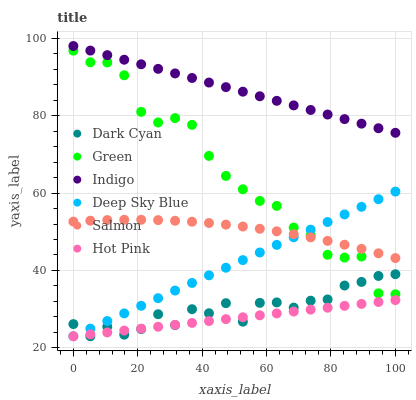Does Hot Pink have the minimum area under the curve?
Answer yes or no. Yes. Does Indigo have the maximum area under the curve?
Answer yes or no. Yes. Does Salmon have the minimum area under the curve?
Answer yes or no. No. Does Salmon have the maximum area under the curve?
Answer yes or no. No. Is Hot Pink the smoothest?
Answer yes or no. Yes. Is Green the roughest?
Answer yes or no. Yes. Is Salmon the smoothest?
Answer yes or no. No. Is Salmon the roughest?
Answer yes or no. No. Does Hot Pink have the lowest value?
Answer yes or no. Yes. Does Salmon have the lowest value?
Answer yes or no. No. Does Indigo have the highest value?
Answer yes or no. Yes. Does Salmon have the highest value?
Answer yes or no. No. Is Hot Pink less than Indigo?
Answer yes or no. Yes. Is Indigo greater than Green?
Answer yes or no. Yes. Does Salmon intersect Green?
Answer yes or no. Yes. Is Salmon less than Green?
Answer yes or no. No. Is Salmon greater than Green?
Answer yes or no. No. Does Hot Pink intersect Indigo?
Answer yes or no. No. 